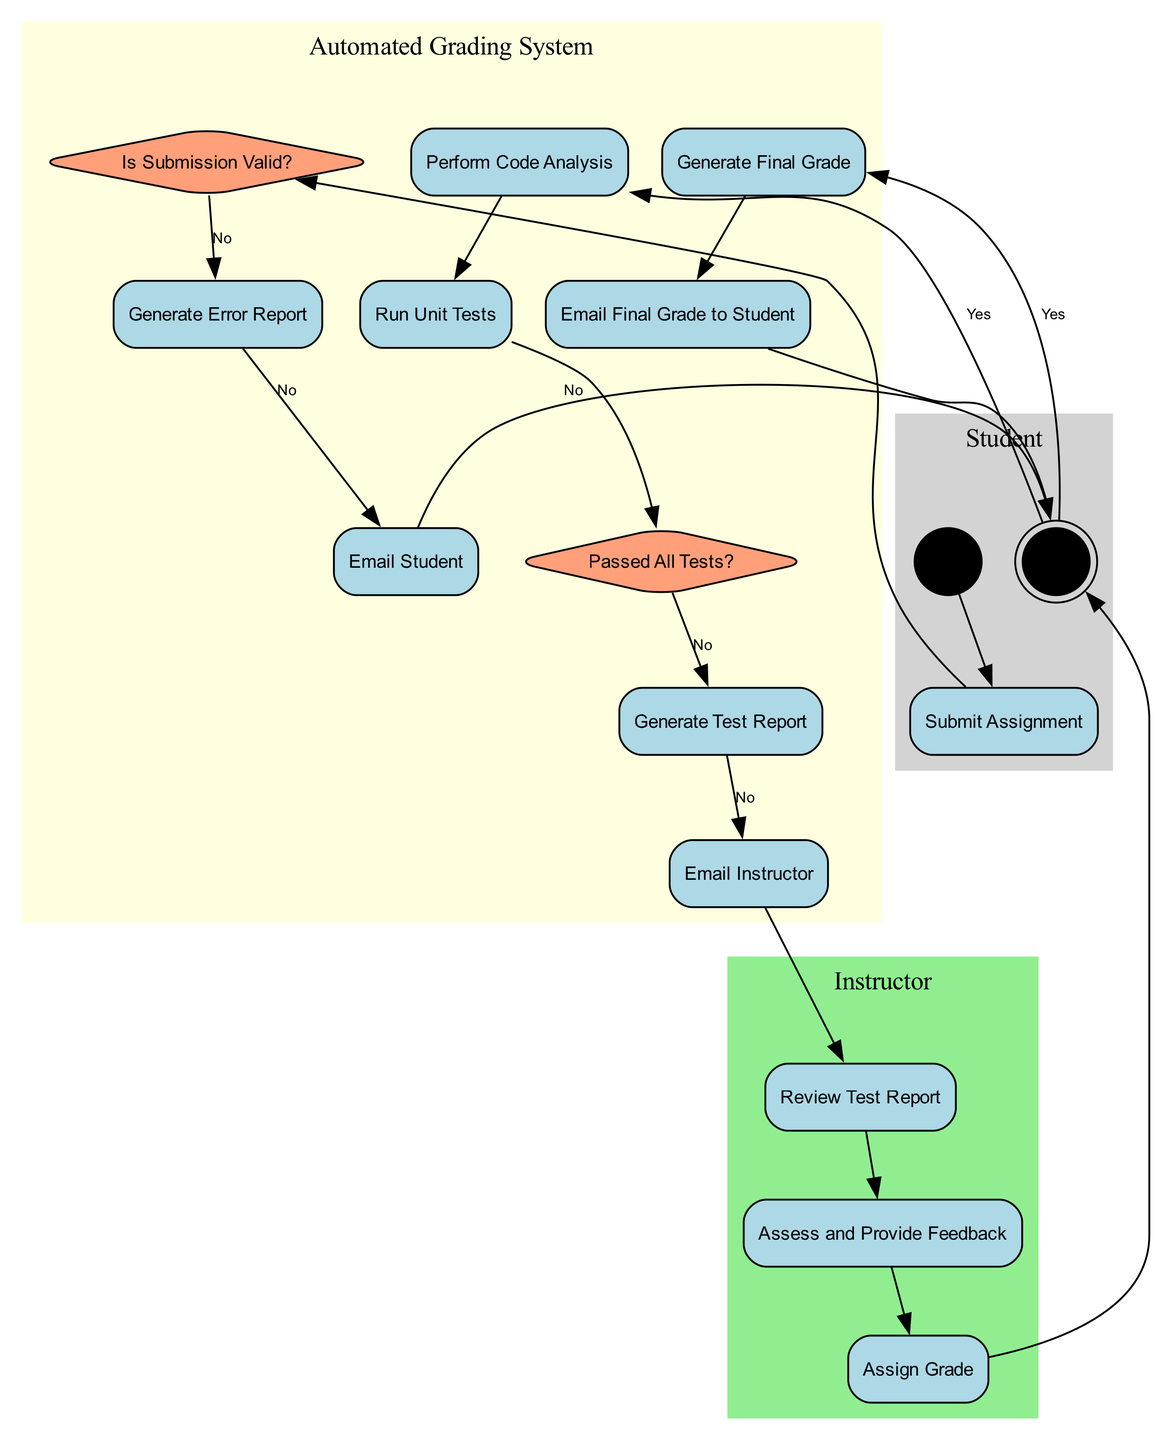What is the first activity in the diagram? The first activity is "Submit Assignment," which appears immediately after the "Assignment Submission" start node under the "Student" swimlane.
Answer: Submit Assignment How many decision points are in the diagram? There are three decision points: "Is Submission Valid?", "Passed All Tests?", and another decision related to generating reports and emailing, represented by the edges that lead to alternatives based on Yes or No outcomes.
Answer: 3 What happens if the submission is valid? If the submission is valid, it leads to the activity "Perform Code Analysis," indicating the process continues through the Automated Grading System swimlane.
Answer: Perform Code Analysis Who reviews the test report? The "Instructor" is responsible for reviewing the test report as indicated in the corresponding swimlane's activities.
Answer: Instructor What activity follows after "Generate Error Report"? After "Generate Error Report," the next activity is "Email Student," indicating the response to the student about the error in their submission.
Answer: Email Student What are the end process nodes? There are three end process nodes: one for the "Student," one for the "Instructor," and one for the "Automated Grading System", each representing a different conclusion to the grading process flow.
Answer: 3 What does the Automated Grading System do after passing all tests? After passing all tests, the Automated Grading System proceeds to "Generate Final Grade," indicating the successful completion of the grading process for the assignment.
Answer: Generate Final Grade Which swimlane contains the activity "Assess and Provide Feedback"? The activity "Assess and Provide Feedback" is located in the "Instructor" swimlane, showing that this role is responsible for providing qualitative feedback on the submissions.
Answer: Instructor What activity does the Student participate in before the grading process completes? The Student participates in "Email Final Grade to Student" before the grading process completes, indicating the final communication step in the process.
Answer: Email Final Grade to Student 